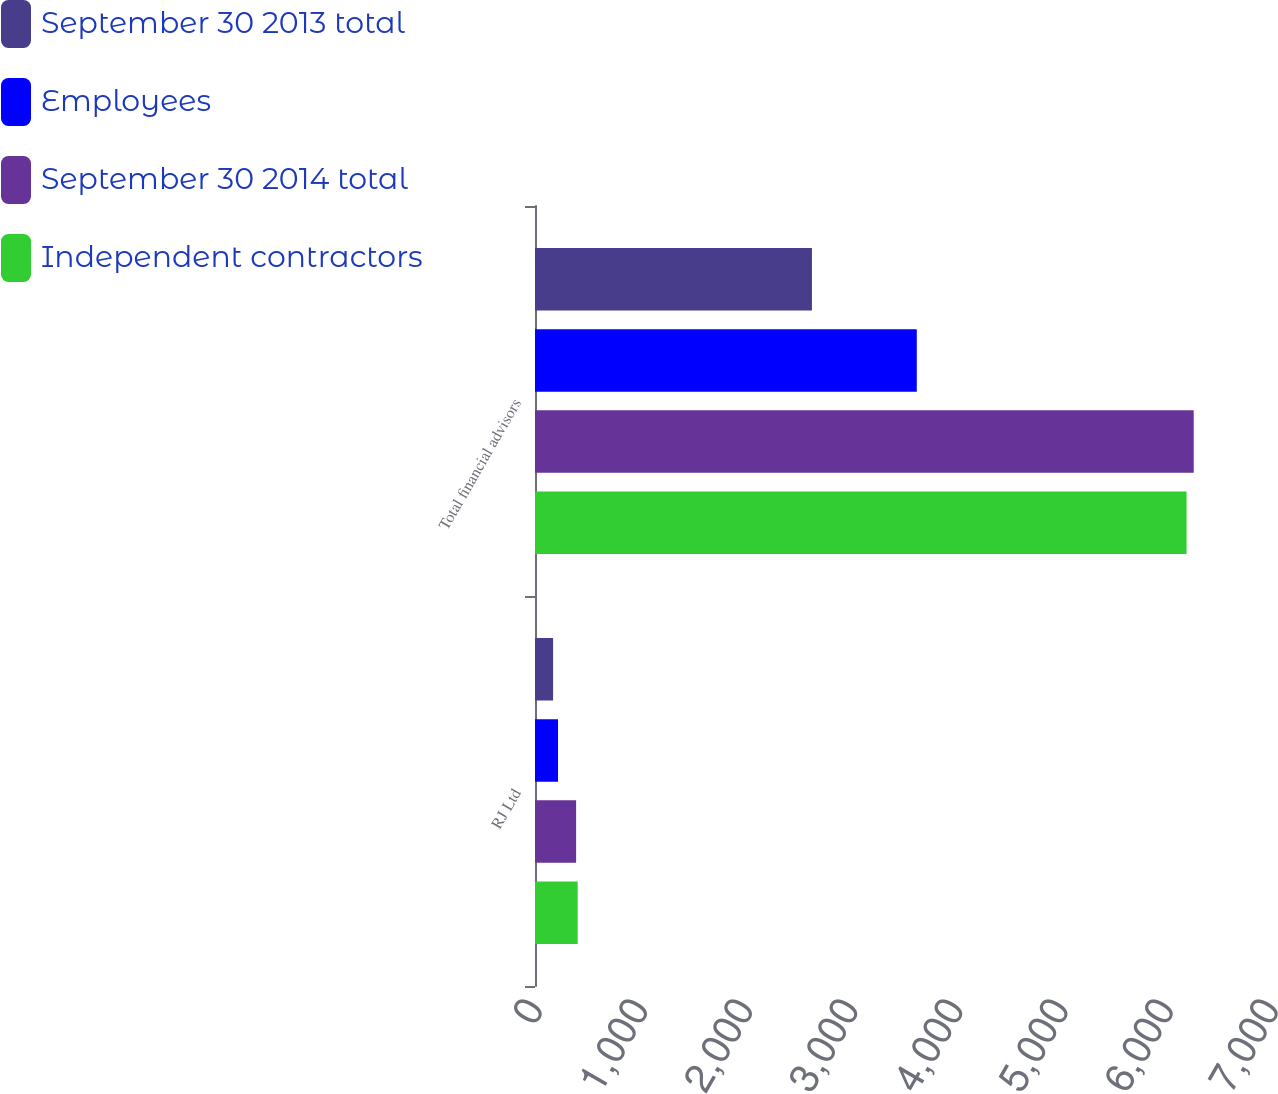Convert chart. <chart><loc_0><loc_0><loc_500><loc_500><stacked_bar_chart><ecel><fcel>RJ Ltd<fcel>Total financial advisors<nl><fcel>September 30 2013 total<fcel>172<fcel>2634<nl><fcel>Employees<fcel>219<fcel>3631<nl><fcel>September 30 2014 total<fcel>391<fcel>6265<nl><fcel>Independent contractors<fcel>406<fcel>6197<nl></chart> 